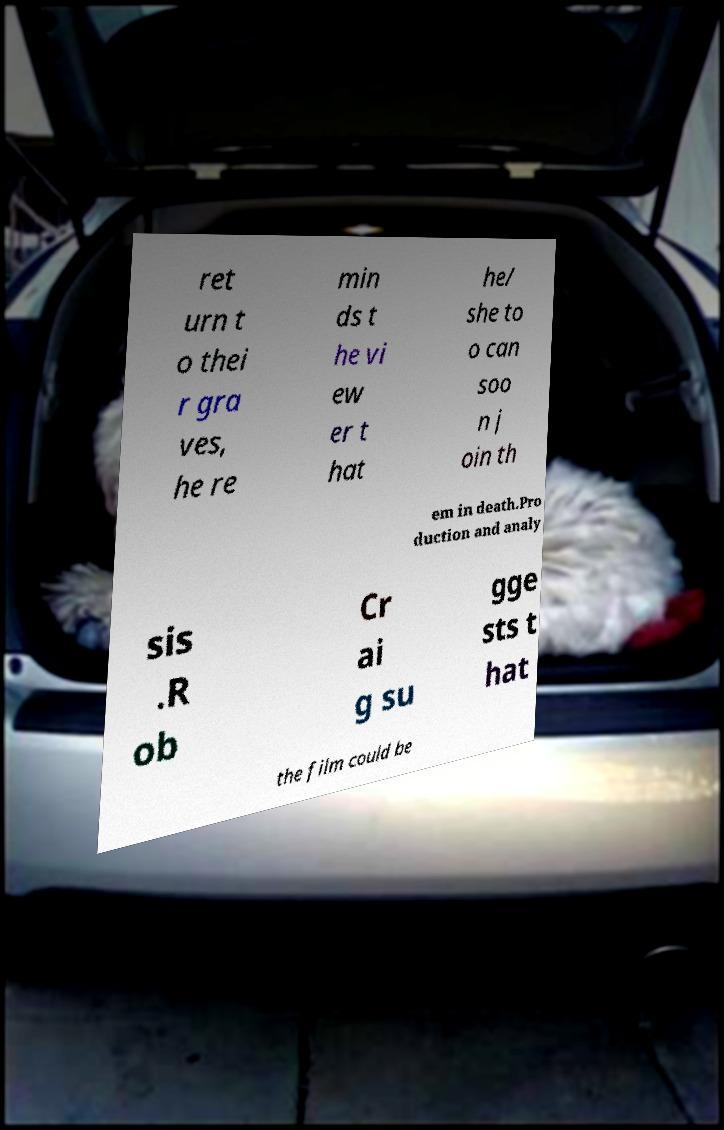Please identify and transcribe the text found in this image. ret urn t o thei r gra ves, he re min ds t he vi ew er t hat he/ she to o can soo n j oin th em in death.Pro duction and analy sis .R ob Cr ai g su gge sts t hat the film could be 